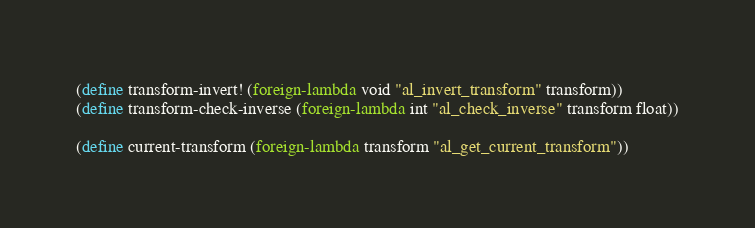Convert code to text. <code><loc_0><loc_0><loc_500><loc_500><_Scheme_>(define transform-invert! (foreign-lambda void "al_invert_transform" transform))
(define transform-check-inverse (foreign-lambda int "al_check_inverse" transform float))

(define current-transform (foreign-lambda transform "al_get_current_transform"))
</code> 